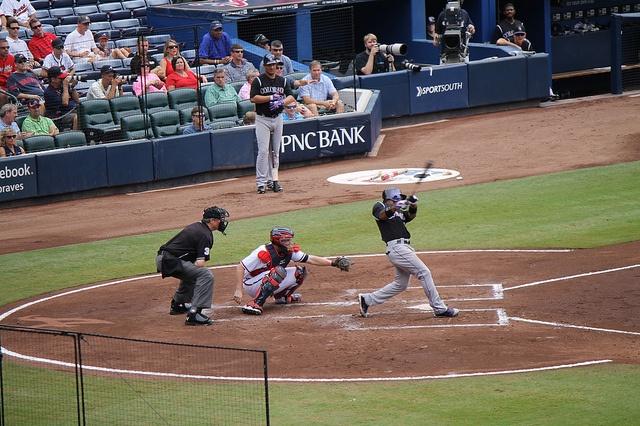Describe the objects in this image and their specific colors. I can see people in darkgray, black, gray, and lavender tones, people in darkgray, black, gray, brown, and olive tones, people in darkgray, black, gray, and lavender tones, people in darkgray, black, brown, gray, and maroon tones, and people in darkgray, black, and gray tones in this image. 